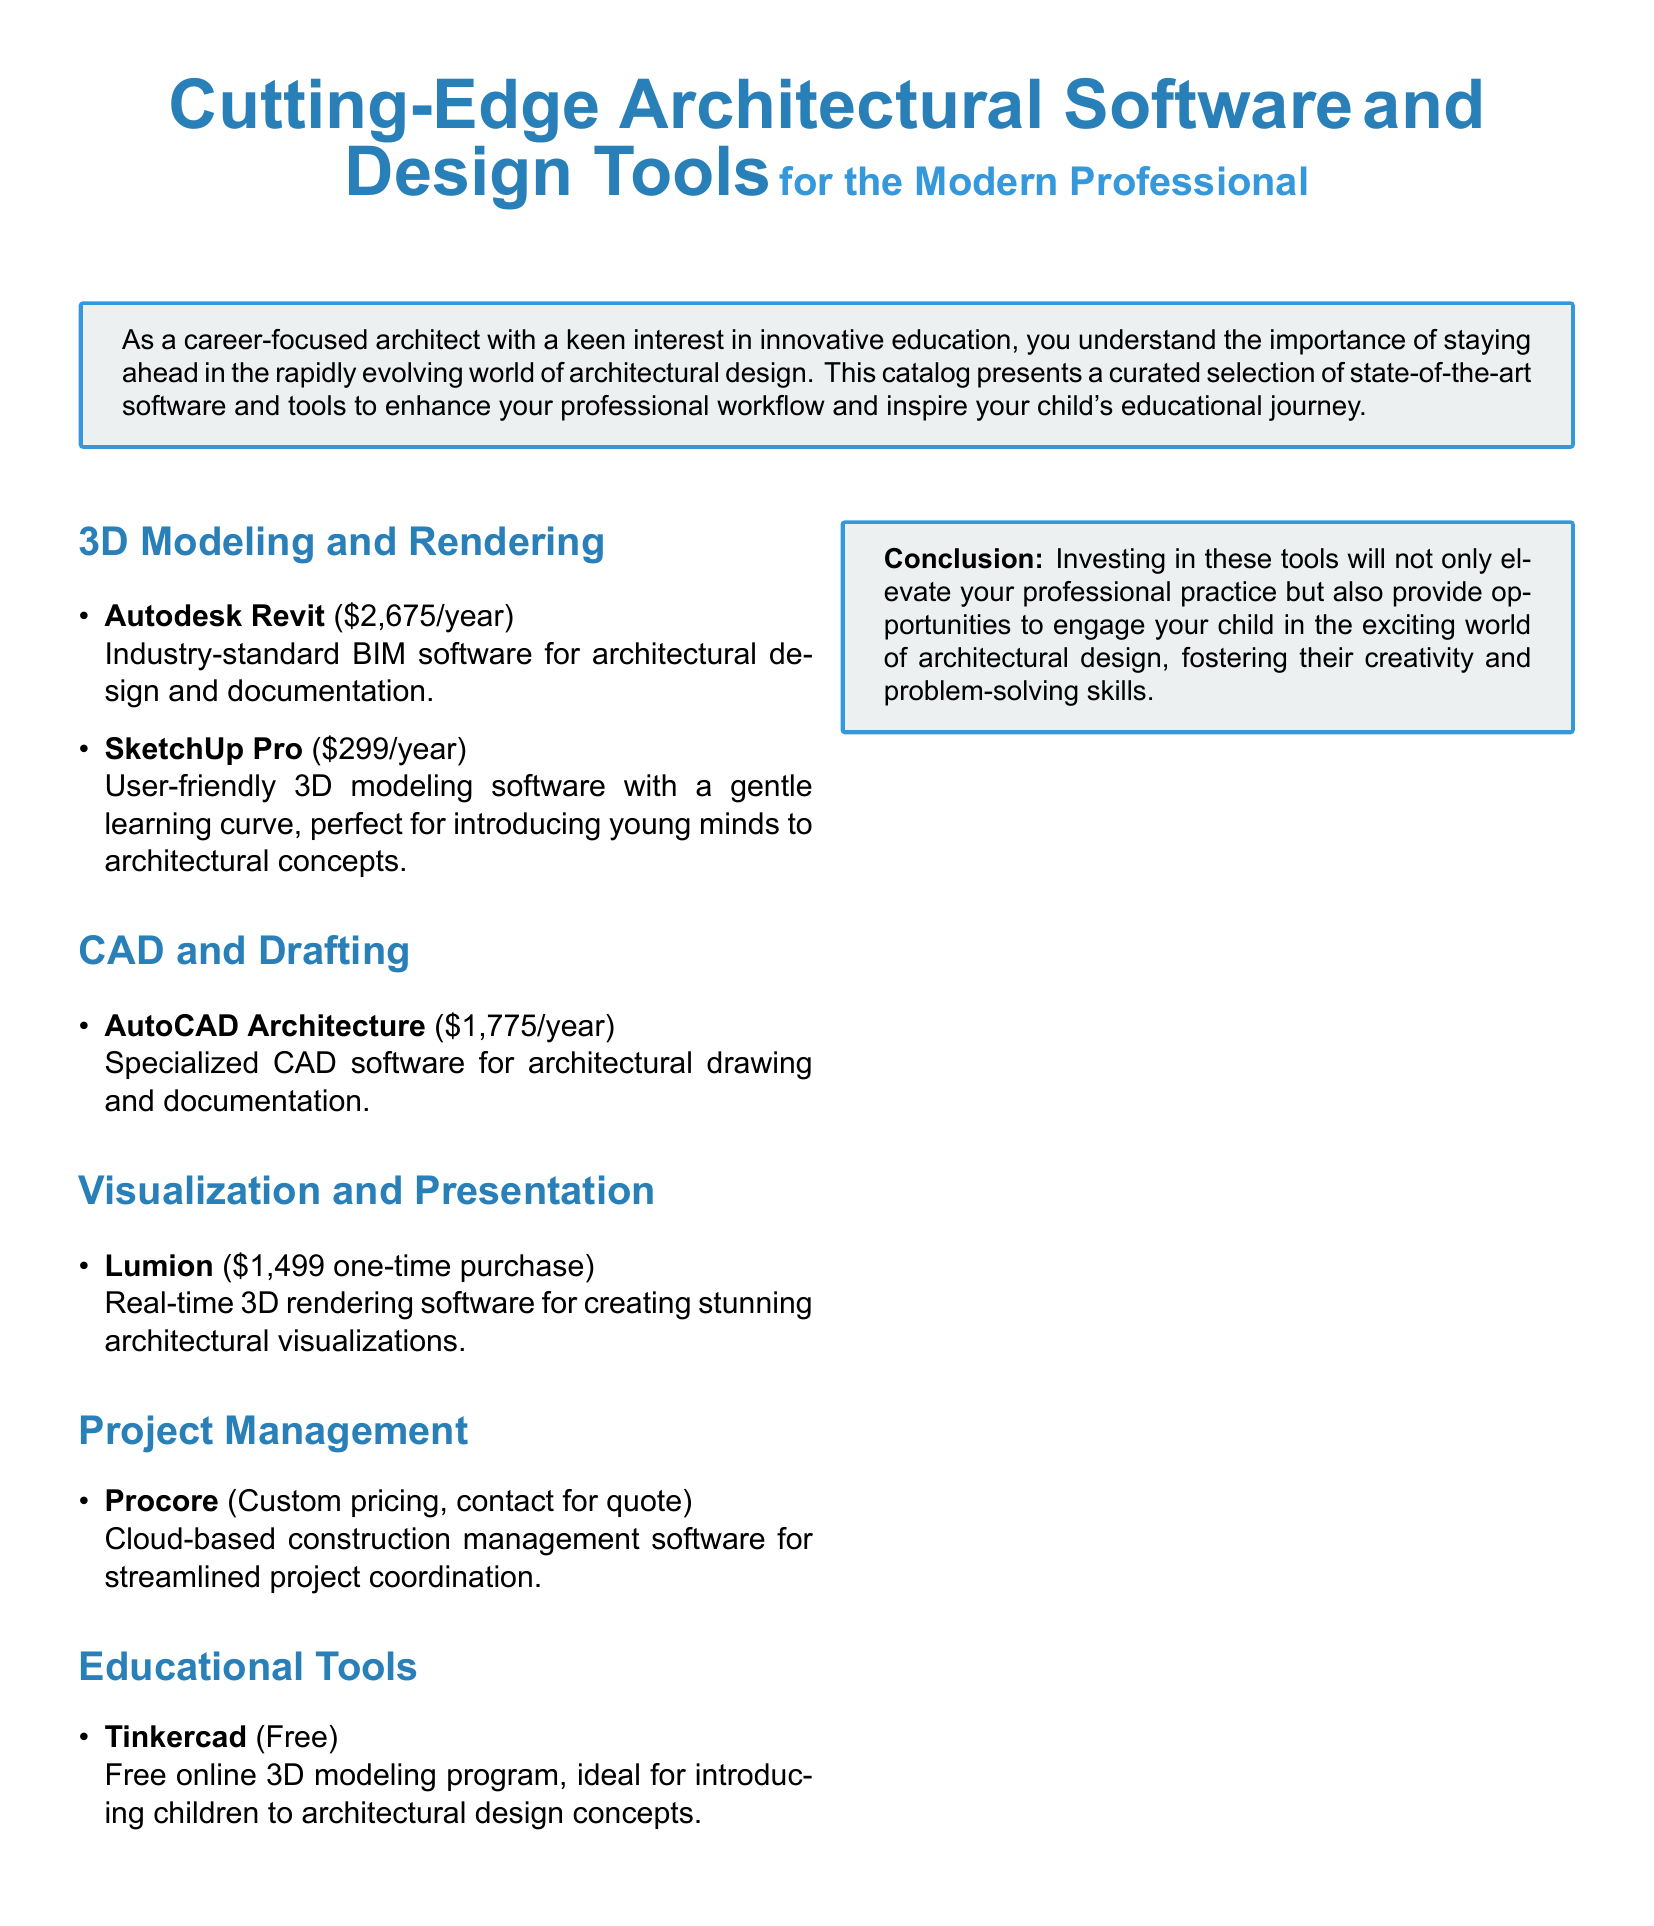what is the price of Autodesk Revit? The price of Autodesk Revit is explicitly listed in the document as $2,675/year.
Answer: $2,675/year what is the purpose of Tinkercad? Tinkercad is described as a free online 3D modeling program ideal for introducing children to architectural design concepts.
Answer: Introducing children to architectural design concepts how much does Lumion cost? The document states that Lumion has a one-time purchase price of $1,499.
Answer: $1,499 one-time purchase what software is specialized for architectural drawing? The document mentions AutoCAD Architecture as the specialized CAD software for architectural drawing and documentation.
Answer: AutoCAD Architecture which software is suggested for young learners? SketchUp Pro is highlighted in the document as user-friendly and ideal for introducing young minds to architectural concepts.
Answer: SketchUp Pro what type of software is Procore? Procore is categorized as cloud-based construction management software for streamlined project coordination.
Answer: Cloud-based construction management software what is the annual cost of AutoCAD Architecture? The document specifies the annual cost of AutoCAD Architecture as $1,775.
Answer: $1,775/year which section discusses visualization tools? The section dedicated to visualization tools in the document is titled "Visualization and Presentation."
Answer: Visualization and Presentation what is the conclusion of the document? The conclusion emphasizes the importance of investing in tools to elevate professional practice and engage children in architectural design.
Answer: Investing in these tools will elevate your professional practice 